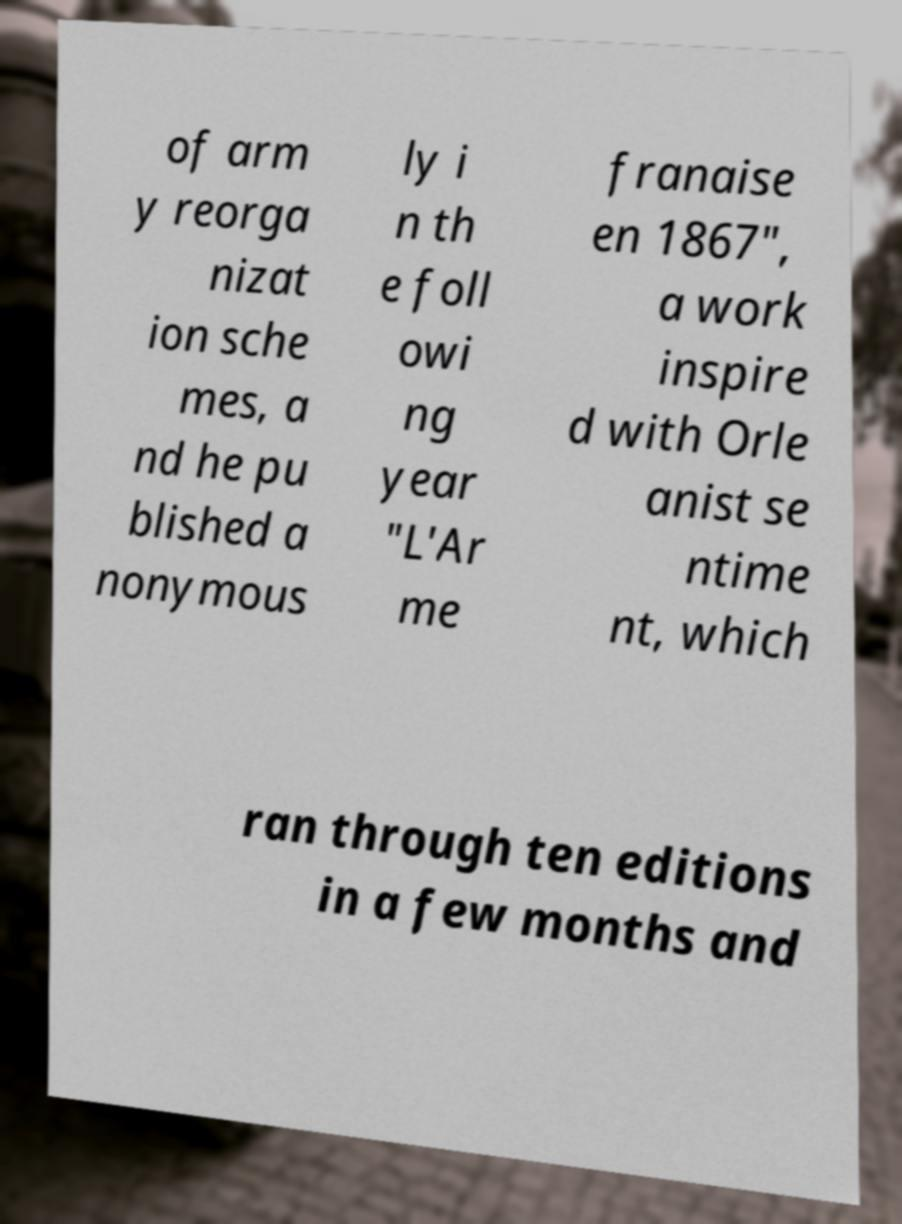Can you accurately transcribe the text from the provided image for me? of arm y reorga nizat ion sche mes, a nd he pu blished a nonymous ly i n th e foll owi ng year "L'Ar me franaise en 1867", a work inspire d with Orle anist se ntime nt, which ran through ten editions in a few months and 